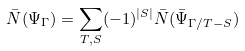<formula> <loc_0><loc_0><loc_500><loc_500>\bar { N } ( \Psi _ { \Gamma } ) = \sum _ { T , S } ( - 1 ) ^ { | S | } \bar { N } ( \bar { \Psi } _ { \Gamma / T - S } )</formula> 